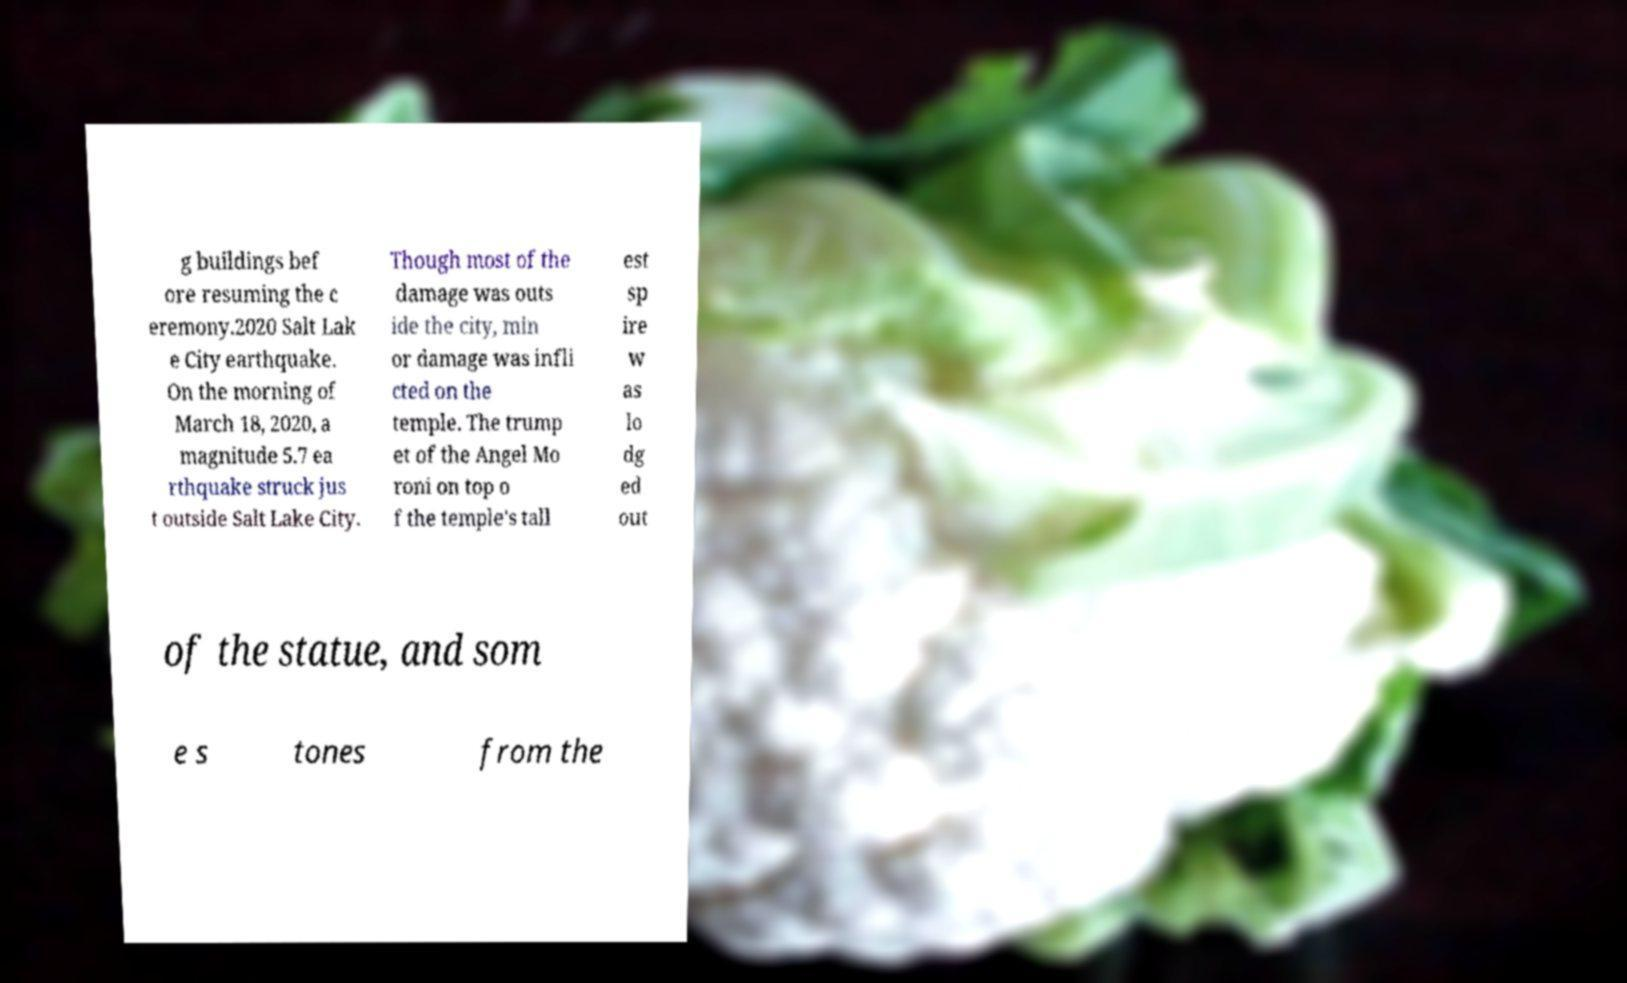There's text embedded in this image that I need extracted. Can you transcribe it verbatim? g buildings bef ore resuming the c eremony.2020 Salt Lak e City earthquake. On the morning of March 18, 2020, a magnitude 5.7 ea rthquake struck jus t outside Salt Lake City. Though most of the damage was outs ide the city, min or damage was infli cted on the temple. The trump et of the Angel Mo roni on top o f the temple's tall est sp ire w as lo dg ed out of the statue, and som e s tones from the 